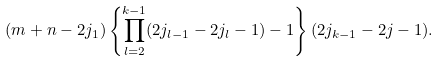<formula> <loc_0><loc_0><loc_500><loc_500>( m + n - 2 j _ { 1 } ) \left \{ \prod _ { l = 2 } ^ { k - 1 } ( 2 j _ { l - 1 } - 2 j _ { l } - 1 ) - 1 \right \} ( 2 j _ { k - 1 } - 2 j - 1 ) .</formula> 